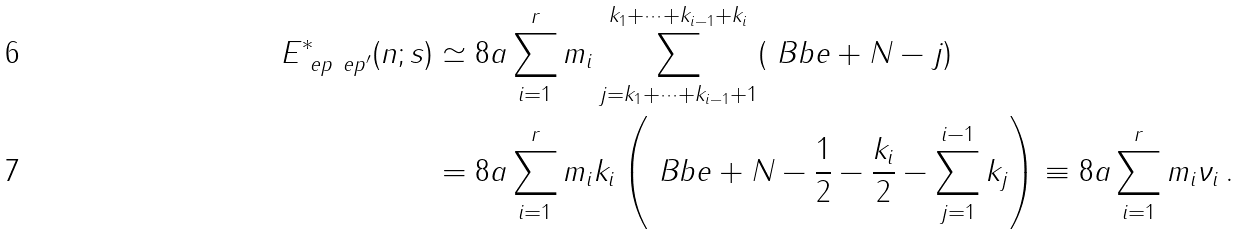Convert formula to latex. <formula><loc_0><loc_0><loc_500><loc_500>E ^ { * } _ { \ e p \ e p ^ { \prime } } ( n ; s ) & \simeq 8 a \sum _ { i = 1 } ^ { r } m _ { i } \sum _ { j = k _ { 1 } + \cdots + k _ { i - 1 } + 1 } ^ { k _ { 1 } + \cdots + k _ { i - 1 } + k _ { i } } ( \ B b e + N - j ) \\ & = 8 a \sum _ { i = 1 } ^ { r } m _ { i } k _ { i } \left ( \ B b e + N - \frac { 1 } { 2 } - \frac { k _ { i } } 2 - \sum _ { j = 1 } ^ { i - 1 } k _ { j } \right ) \equiv 8 a \sum _ { i = 1 } ^ { r } m _ { i } \nu _ { i } \, .</formula> 